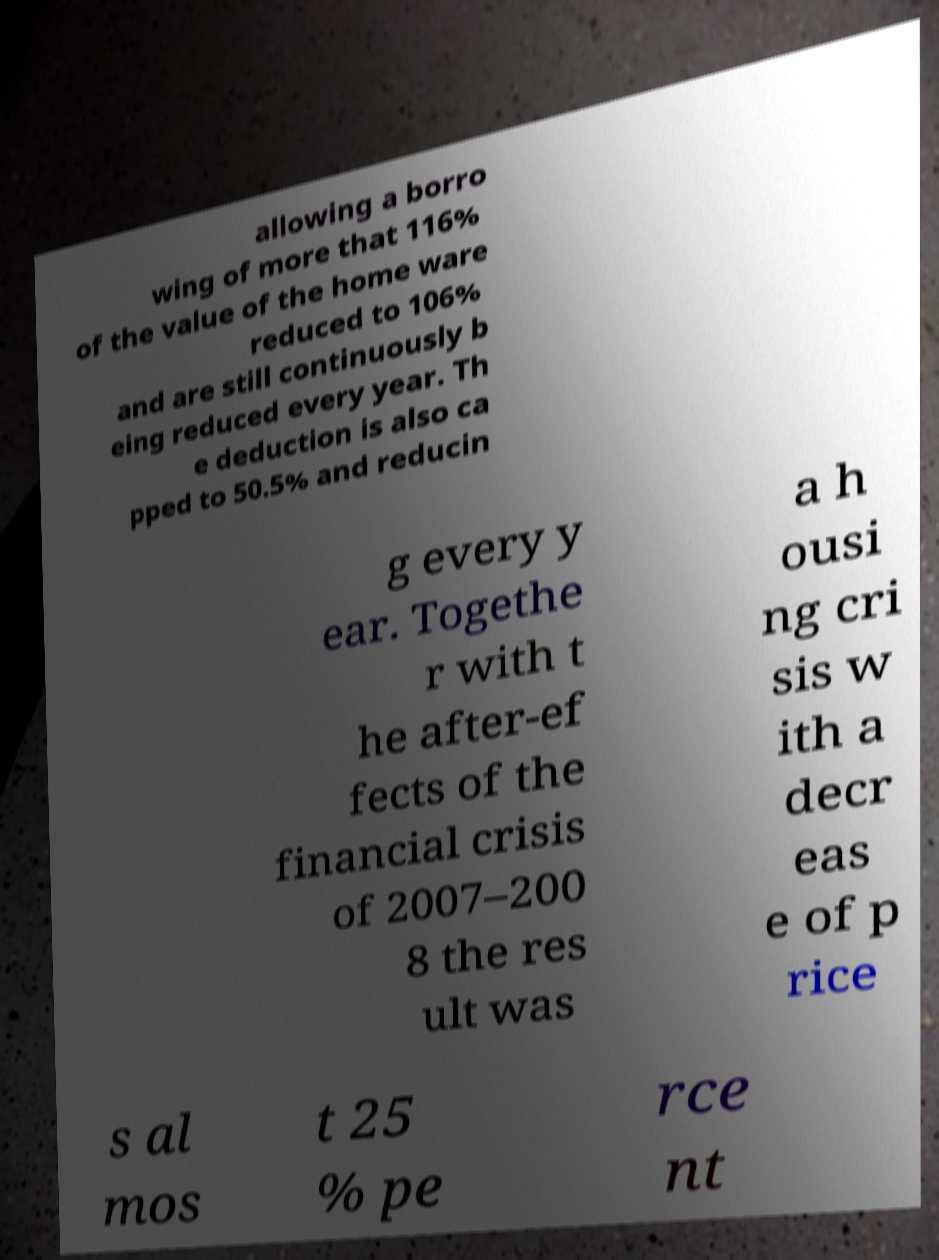Could you extract and type out the text from this image? allowing a borro wing of more that 116% of the value of the home ware reduced to 106% and are still continuously b eing reduced every year. Th e deduction is also ca pped to 50.5% and reducin g every y ear. Togethe r with t he after-ef fects of the financial crisis of 2007–200 8 the res ult was a h ousi ng cri sis w ith a decr eas e of p rice s al mos t 25 % pe rce nt 